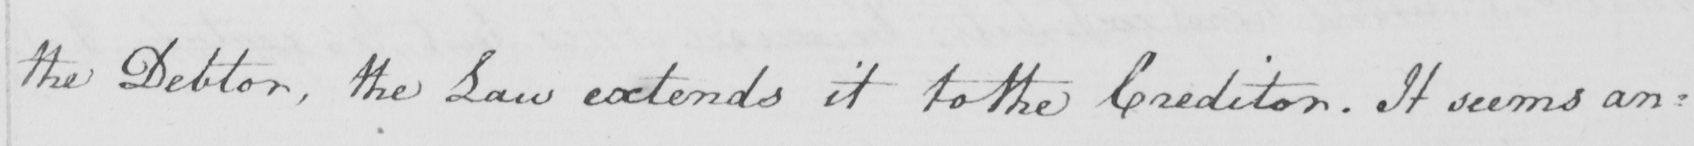What does this handwritten line say? the Debtor , the Law extends it to the Creditor . It seems an= 